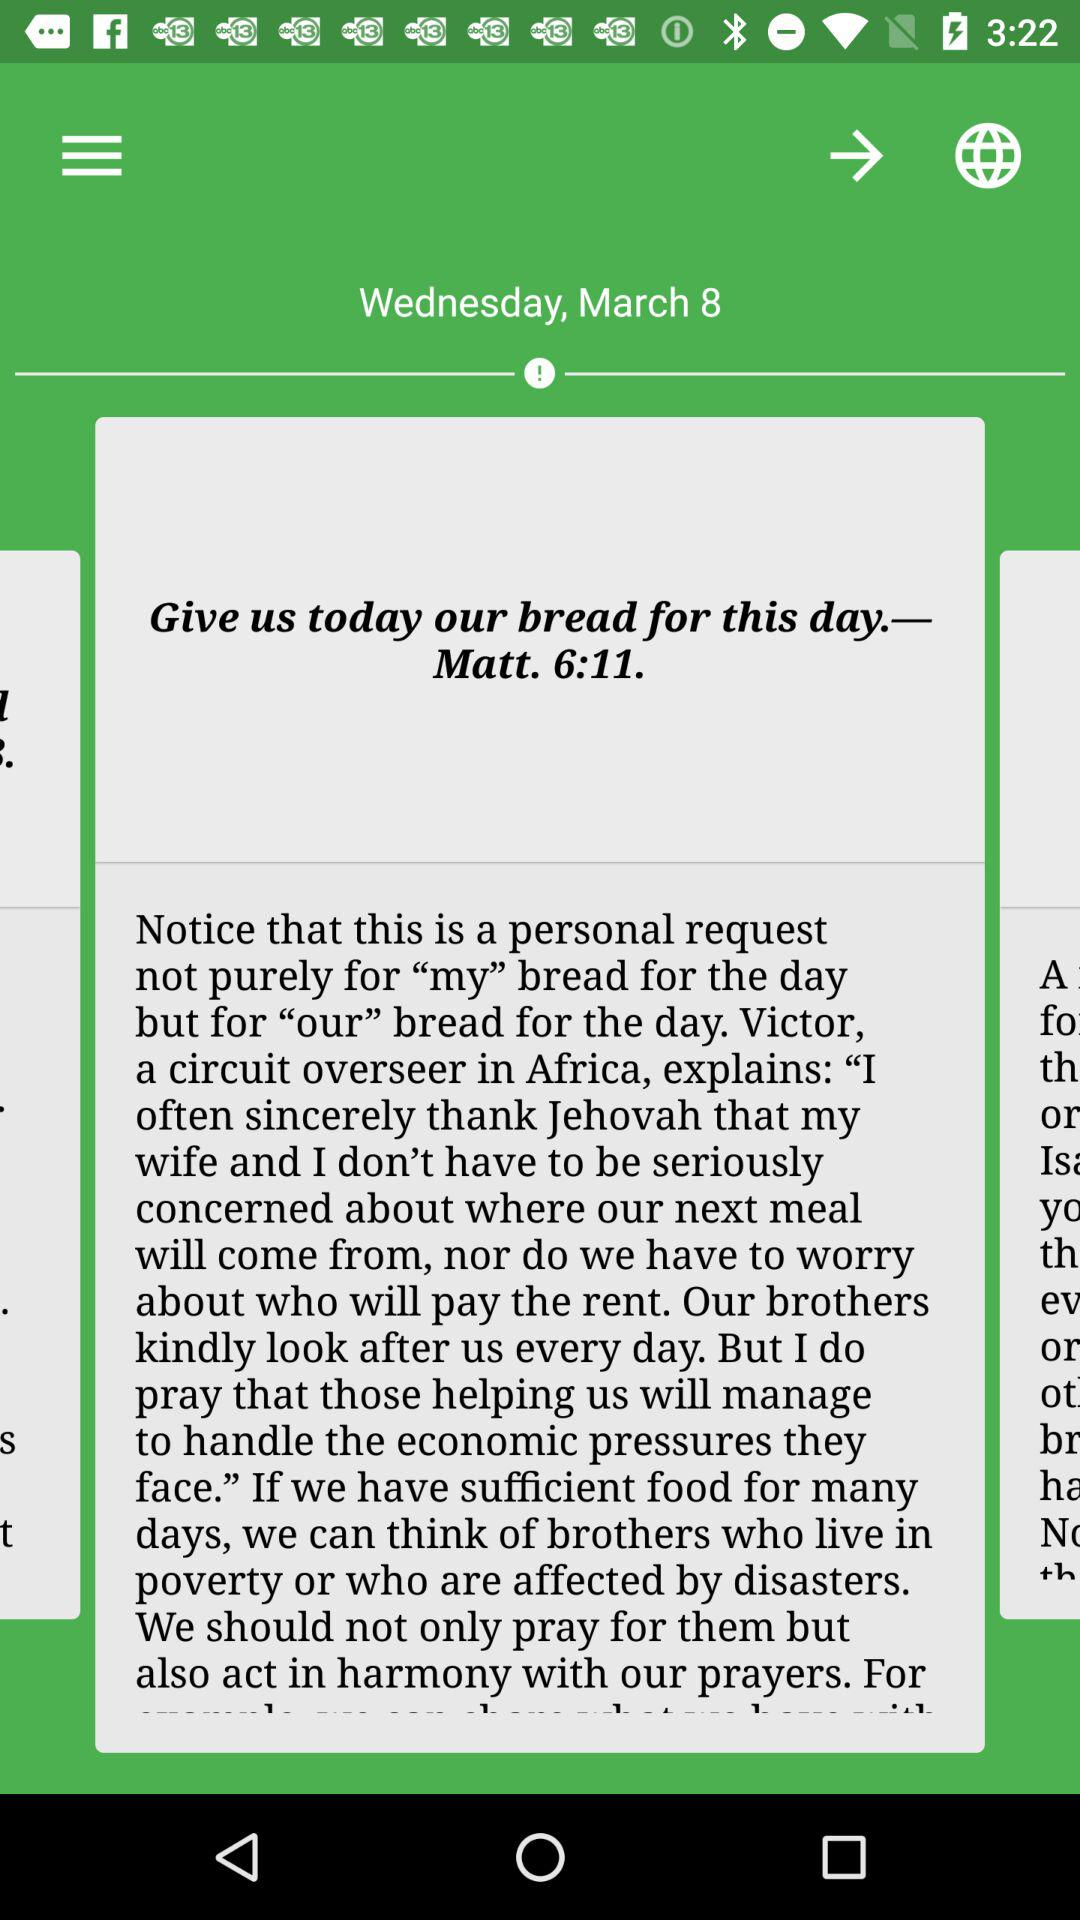What is the selected date? The selected date is Wednesday, March 8. 